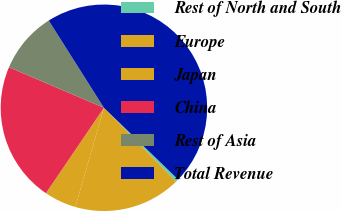Convert chart. <chart><loc_0><loc_0><loc_500><loc_500><pie_chart><fcel>Rest of North and South<fcel>Europe<fcel>Japan<fcel>China<fcel>Rest of Asia<fcel>Total Revenue<nl><fcel>0.45%<fcel>16.78%<fcel>5.03%<fcel>21.93%<fcel>9.6%<fcel>46.21%<nl></chart> 